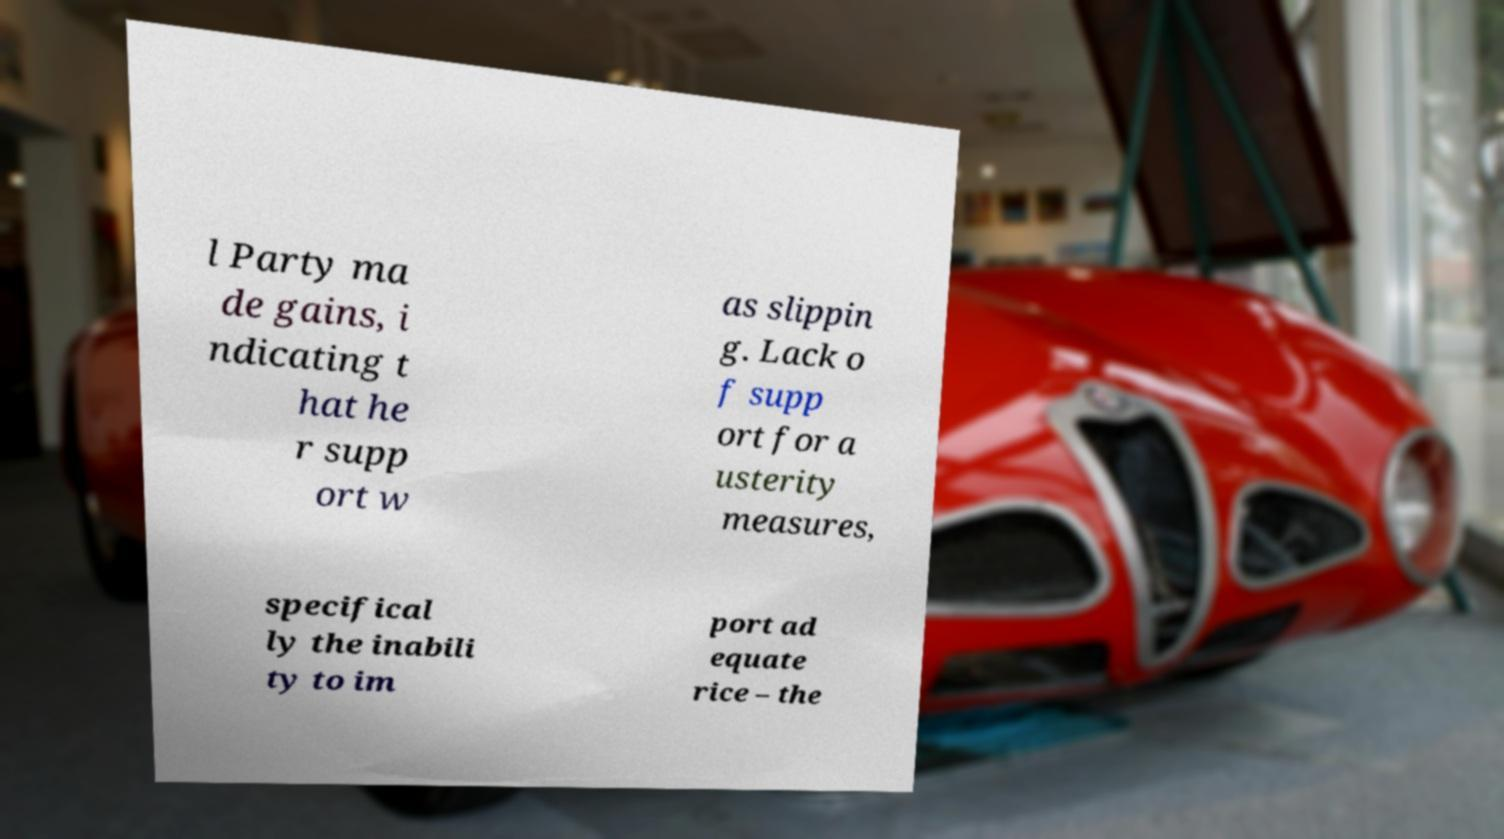There's text embedded in this image that I need extracted. Can you transcribe it verbatim? l Party ma de gains, i ndicating t hat he r supp ort w as slippin g. Lack o f supp ort for a usterity measures, specifical ly the inabili ty to im port ad equate rice – the 